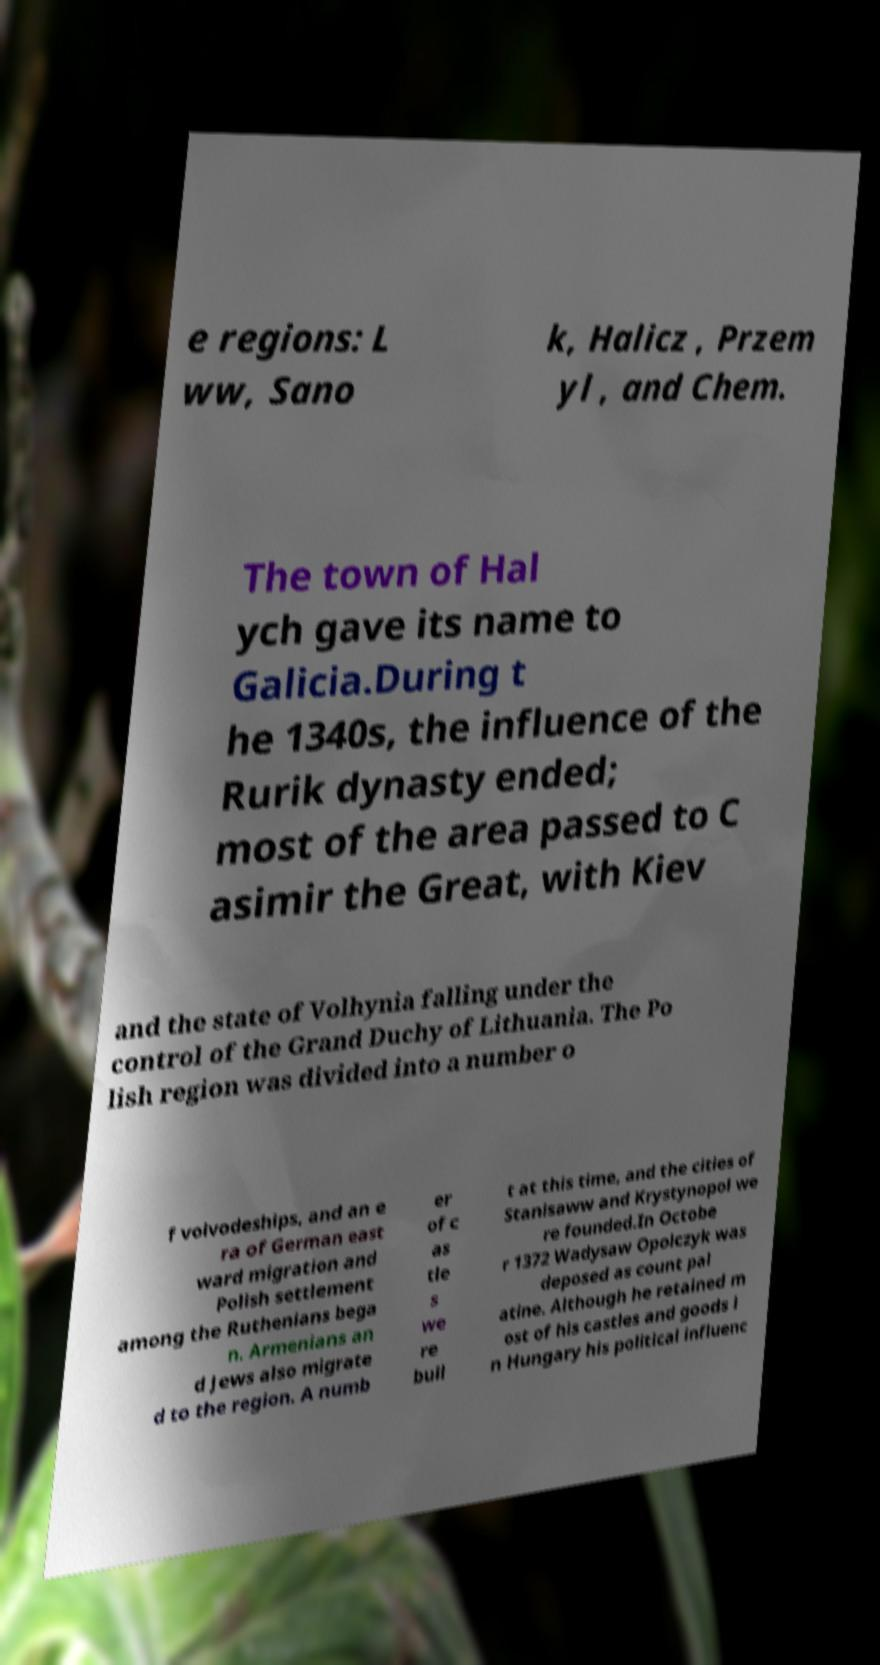Can you accurately transcribe the text from the provided image for me? e regions: L ww, Sano k, Halicz , Przem yl , and Chem. The town of Hal ych gave its name to Galicia.During t he 1340s, the influence of the Rurik dynasty ended; most of the area passed to C asimir the Great, with Kiev and the state of Volhynia falling under the control of the Grand Duchy of Lithuania. The Po lish region was divided into a number o f voivodeships, and an e ra of German east ward migration and Polish settlement among the Ruthenians bega n. Armenians an d Jews also migrate d to the region. A numb er of c as tle s we re buil t at this time, and the cities of Stanisaww and Krystynopol we re founded.In Octobe r 1372 Wadysaw Opolczyk was deposed as count pal atine. Although he retained m ost of his castles and goods i n Hungary his political influenc 